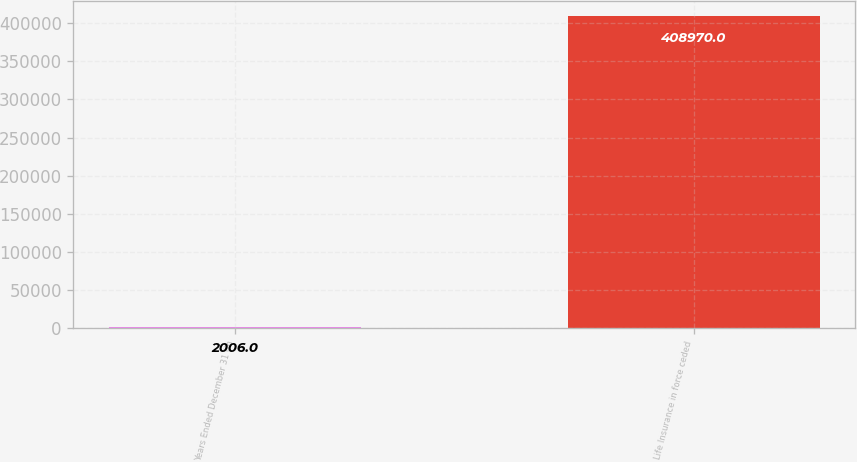Convert chart to OTSL. <chart><loc_0><loc_0><loc_500><loc_500><bar_chart><fcel>Years Ended December 31 (in<fcel>Life Insurance in force ceded<nl><fcel>2006<fcel>408970<nl></chart> 